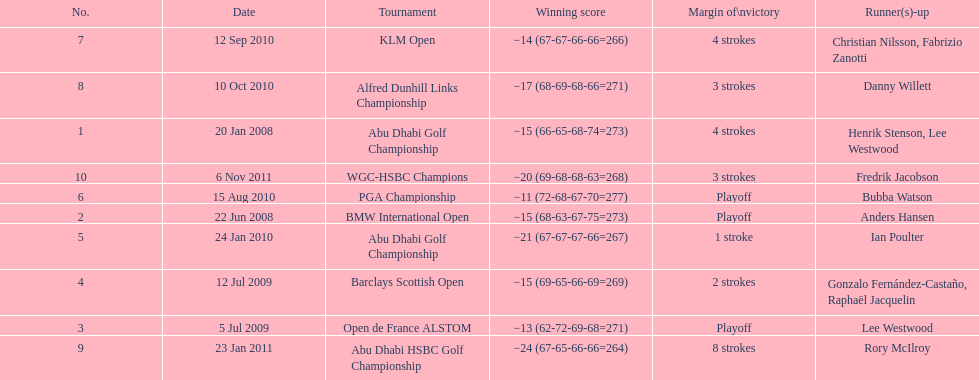Write the full table. {'header': ['No.', 'Date', 'Tournament', 'Winning score', 'Margin of\\nvictory', 'Runner(s)-up'], 'rows': [['7', '12 Sep 2010', 'KLM Open', '−14 (67-67-66-66=266)', '4 strokes', 'Christian Nilsson, Fabrizio Zanotti'], ['8', '10 Oct 2010', 'Alfred Dunhill Links Championship', '−17 (68-69-68-66=271)', '3 strokes', 'Danny Willett'], ['1', '20 Jan 2008', 'Abu Dhabi Golf Championship', '−15 (66-65-68-74=273)', '4 strokes', 'Henrik Stenson, Lee Westwood'], ['10', '6 Nov 2011', 'WGC-HSBC Champions', '−20 (69-68-68-63=268)', '3 strokes', 'Fredrik Jacobson'], ['6', '15 Aug 2010', 'PGA Championship', '−11 (72-68-67-70=277)', 'Playoff', 'Bubba Watson'], ['2', '22 Jun 2008', 'BMW International Open', '−15 (68-63-67-75=273)', 'Playoff', 'Anders Hansen'], ['5', '24 Jan 2010', 'Abu Dhabi Golf Championship', '−21 (67-67-67-66=267)', '1 stroke', 'Ian Poulter'], ['4', '12 Jul 2009', 'Barclays Scottish Open', '−15 (69-65-66-69=269)', '2 strokes', 'Gonzalo Fernández-Castaño, Raphaël Jacquelin'], ['3', '5 Jul 2009', 'Open de France ALSTOM', '−13 (62-72-69-68=271)', 'Playoff', 'Lee Westwood'], ['9', '23 Jan 2011', 'Abu Dhabi HSBC Golf Championship', '−24 (67-65-66-66=264)', '8 strokes', 'Rory McIlroy']]} How many more strokes were in the klm open than the barclays scottish open? 2 strokes. 